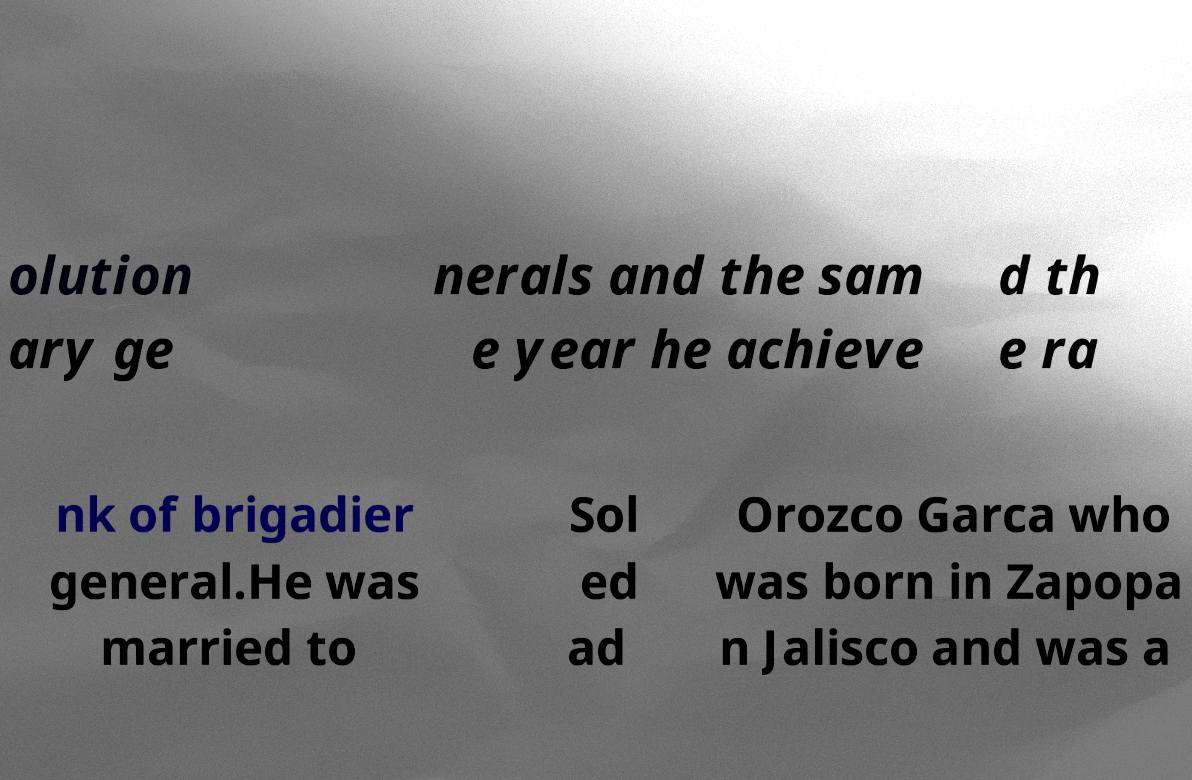Could you assist in decoding the text presented in this image and type it out clearly? olution ary ge nerals and the sam e year he achieve d th e ra nk of brigadier general.He was married to Sol ed ad Orozco Garca who was born in Zapopa n Jalisco and was a 